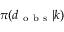<formula> <loc_0><loc_0><loc_500><loc_500>\pi ( d _ { o b s } | k )</formula> 